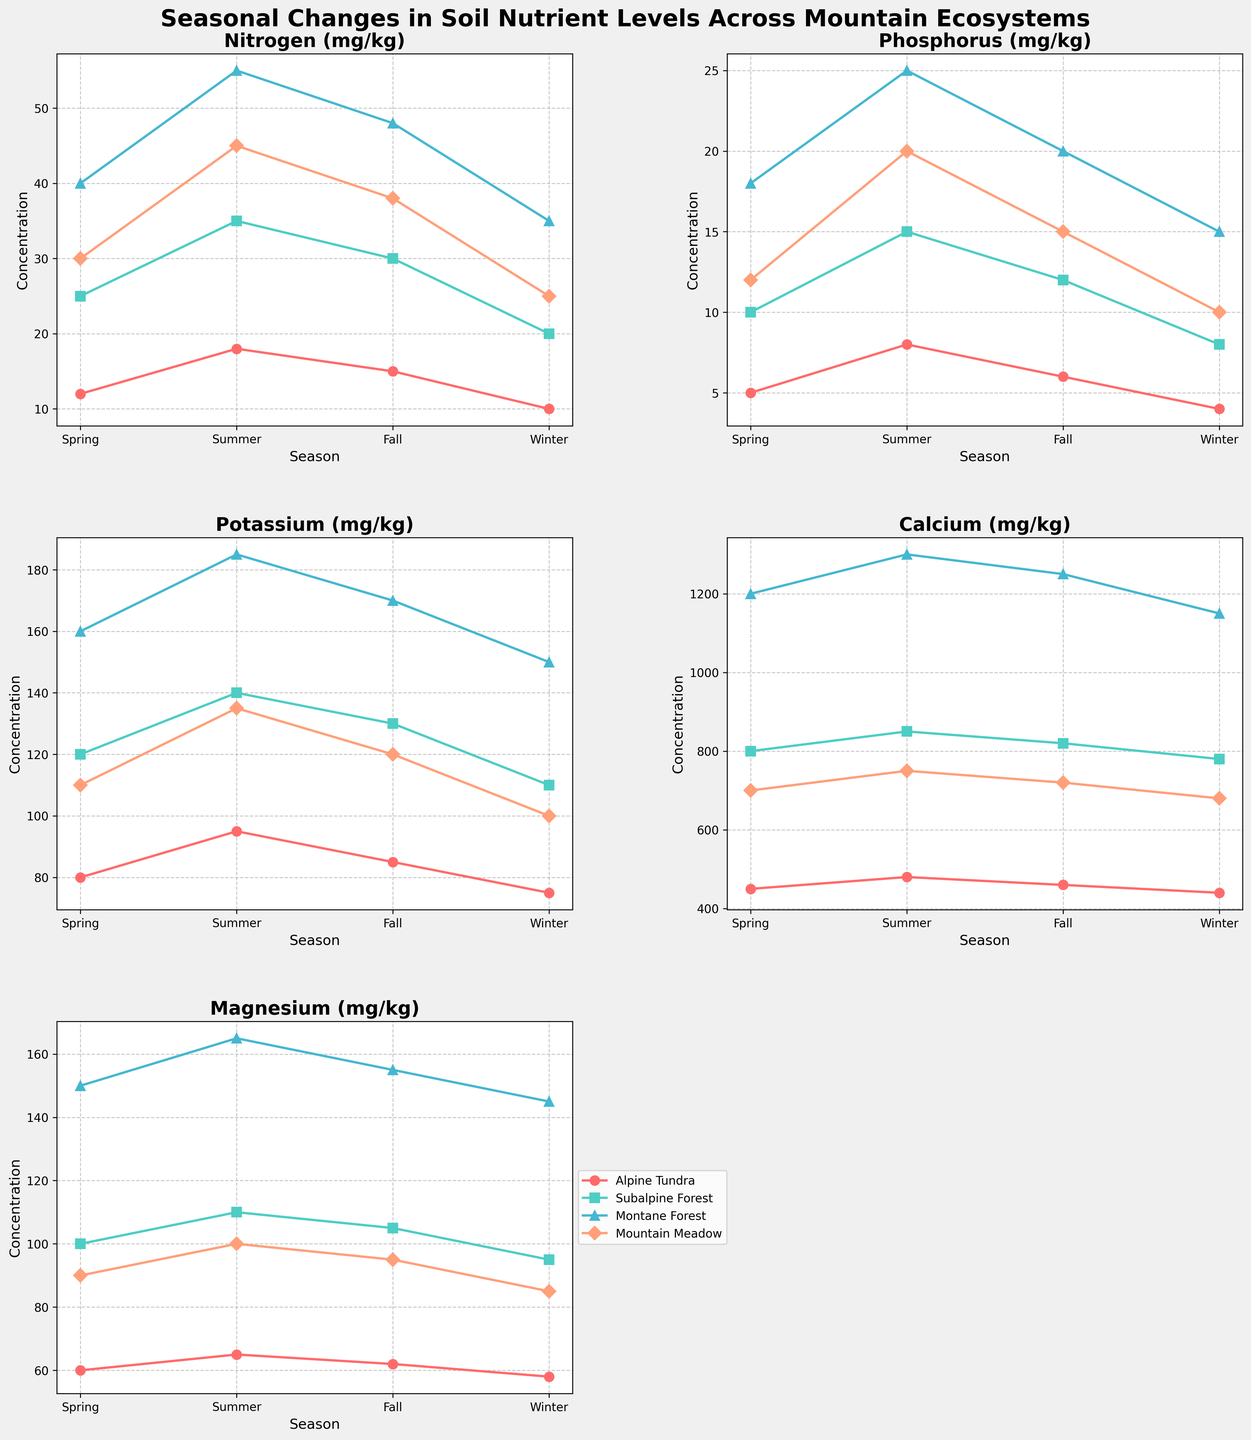Which ecosystem shows the highest nitrogen concentration in summer? First, locate the subplot for Nitrogen (mg/kg). Then, check the lines corresponding to each ecosystem and note the nitrogen levels in summer. Montane Forest has the highest nitrogen concentration at 55 mg/kg.
Answer: Montane Forest What is the average magnesium concentration in the Alpine Tundra across all seasons? Check the subplot for Magnesium (mg/kg) and observe the values for Alpine Tundra across all seasons: Spring 60, Summer 65, Fall 62, Winter 58. Calculate the average: (60+65+62+58) / 4 = 61.25 mg/kg.
Answer: 61.25 mg/kg By how much does the potassium concentration increase from spring to summer in the Montane Forest? Locate the subplot for Potassium (mg/kg). Find the Montane Forest potassium values for Spring (160 mg/kg) and Summer (185 mg/kg). The increase is 185 - 160 = 25 mg/kg.
Answer: 25 mg/kg Which nutrient has the least variation in concentration across seasons in the Subalpine Forest? Compare the extent of changes across seasons for each nutrient in the Subalpine Forest. Magnesium varies from 95 to 110, Calcium from 780 to 850, Potassium from 110 to 140, Phosphorus from 8 to 15, and Nitrogen from 20 to 35. Magnesium shows the least variation.
Answer: Magnesium Does the nitrogen concentration in the Mountain Meadow ever exceed that in the Montane Forest in any season? Examine the subplot for Nitrogen (mg/kg). Observe the nitrogen levels in Mountain Meadow (30, 45, 38, 25) and in Montane Forest (40, 55, 48, 35) for all seasons. Mountain Meadow's nitrogen never exceeds that in Montane Forest.
Answer: No During which season is the calcium concentration the lowest for all ecosystems combined? Locate the subplot for Calcium (mg/kg) and observe the lines for each ecosystem across seasons. The lowest values across all ecosystems occur in Winter: Alpine Tundra (440), Subalpine Forest (780), Montane Forest (1150), Mountain Meadow (680). Winter has the lowest combined.
Answer: Winter Which season shows the greatest change in phosphorus concentration in the Montane Forest? Observe the subplot for Phosphorus (mg/kg). Look at the changes between seasons for Montane Forest: from Spring (18) to Summer (25) is 7, Summer to Fall (20) is -5, Fall to Winter (15) is -5. Spring to Summer shows the greatest change (7 mg/kg).
Answer: Spring to Summer Is the magnesium concentration higher in the Subalpine Forest or Montane Forest during fall? Find the subplot for Magnesium (mg/kg) and compare the fall values: Subalpine Forest (105 mg/kg) and Montane Forest (155 mg/kg). Montane Forest is higher.
Answer: Montane Forest What is the difference in phosphorus concentration between winter and spring in the Mountain Meadow? Check the subplot for Phosphorus (mg/kg) and note the values for Mountain Meadow in Winter (10 mg/kg) and Spring (12 mg/kg). The difference is 12 - 10 = 2 mg/kg.
Answer: 2 mg/kg Which ecosystem has the most constant potassium levels across seasons? Locate the subplot for Potassium (mg/kg). Examine the variation for each ecosystem: Alpine Tundra (75-95), Subalpine Forest (110-140), Montane Forest (150-185), Mountain Meadow (100-135). Alpine Tundra has the smallest range (20 mg/kg).
Answer: Alpine Tundra 